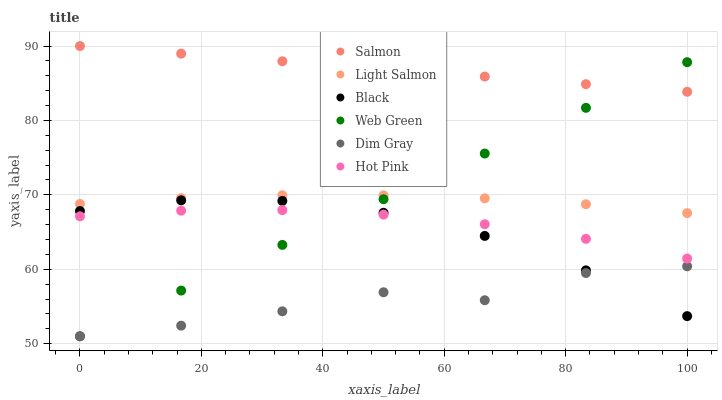Does Dim Gray have the minimum area under the curve?
Answer yes or no. Yes. Does Salmon have the maximum area under the curve?
Answer yes or no. Yes. Does Hot Pink have the minimum area under the curve?
Answer yes or no. No. Does Hot Pink have the maximum area under the curve?
Answer yes or no. No. Is Web Green the smoothest?
Answer yes or no. Yes. Is Dim Gray the roughest?
Answer yes or no. Yes. Is Hot Pink the smoothest?
Answer yes or no. No. Is Hot Pink the roughest?
Answer yes or no. No. Does Dim Gray have the lowest value?
Answer yes or no. Yes. Does Hot Pink have the lowest value?
Answer yes or no. No. Does Salmon have the highest value?
Answer yes or no. Yes. Does Hot Pink have the highest value?
Answer yes or no. No. Is Dim Gray less than Salmon?
Answer yes or no. Yes. Is Hot Pink greater than Dim Gray?
Answer yes or no. Yes. Does Web Green intersect Dim Gray?
Answer yes or no. Yes. Is Web Green less than Dim Gray?
Answer yes or no. No. Is Web Green greater than Dim Gray?
Answer yes or no. No. Does Dim Gray intersect Salmon?
Answer yes or no. No. 